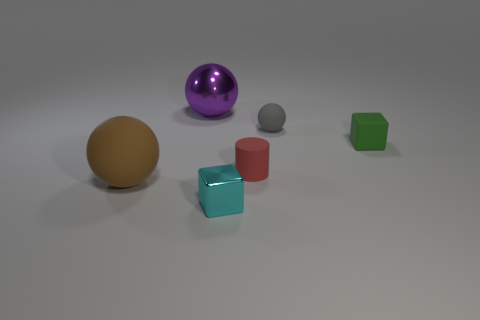Are there more small matte things that are in front of the small gray rubber sphere than small red spheres?
Your response must be concise. Yes. The green object that is the same size as the gray thing is what shape?
Offer a terse response. Cube. How many things are to the right of the tiny block in front of the rubber object on the left side of the cyan shiny block?
Your answer should be very brief. 3. What number of matte things are small red things or small cyan objects?
Offer a terse response. 1. There is a thing that is both behind the green object and right of the cylinder; what color is it?
Your response must be concise. Gray. Does the block in front of the matte block have the same size as the purple object?
Your answer should be very brief. No. What number of objects are matte objects on the left side of the gray ball or big green cylinders?
Offer a terse response. 2. Is there a red cylinder that has the same size as the gray matte sphere?
Offer a terse response. Yes. There is a green block that is the same size as the red cylinder; what is its material?
Provide a short and direct response. Rubber. There is a tiny matte object that is both in front of the tiny gray rubber ball and to the right of the small red rubber cylinder; what shape is it?
Offer a very short reply. Cube. 